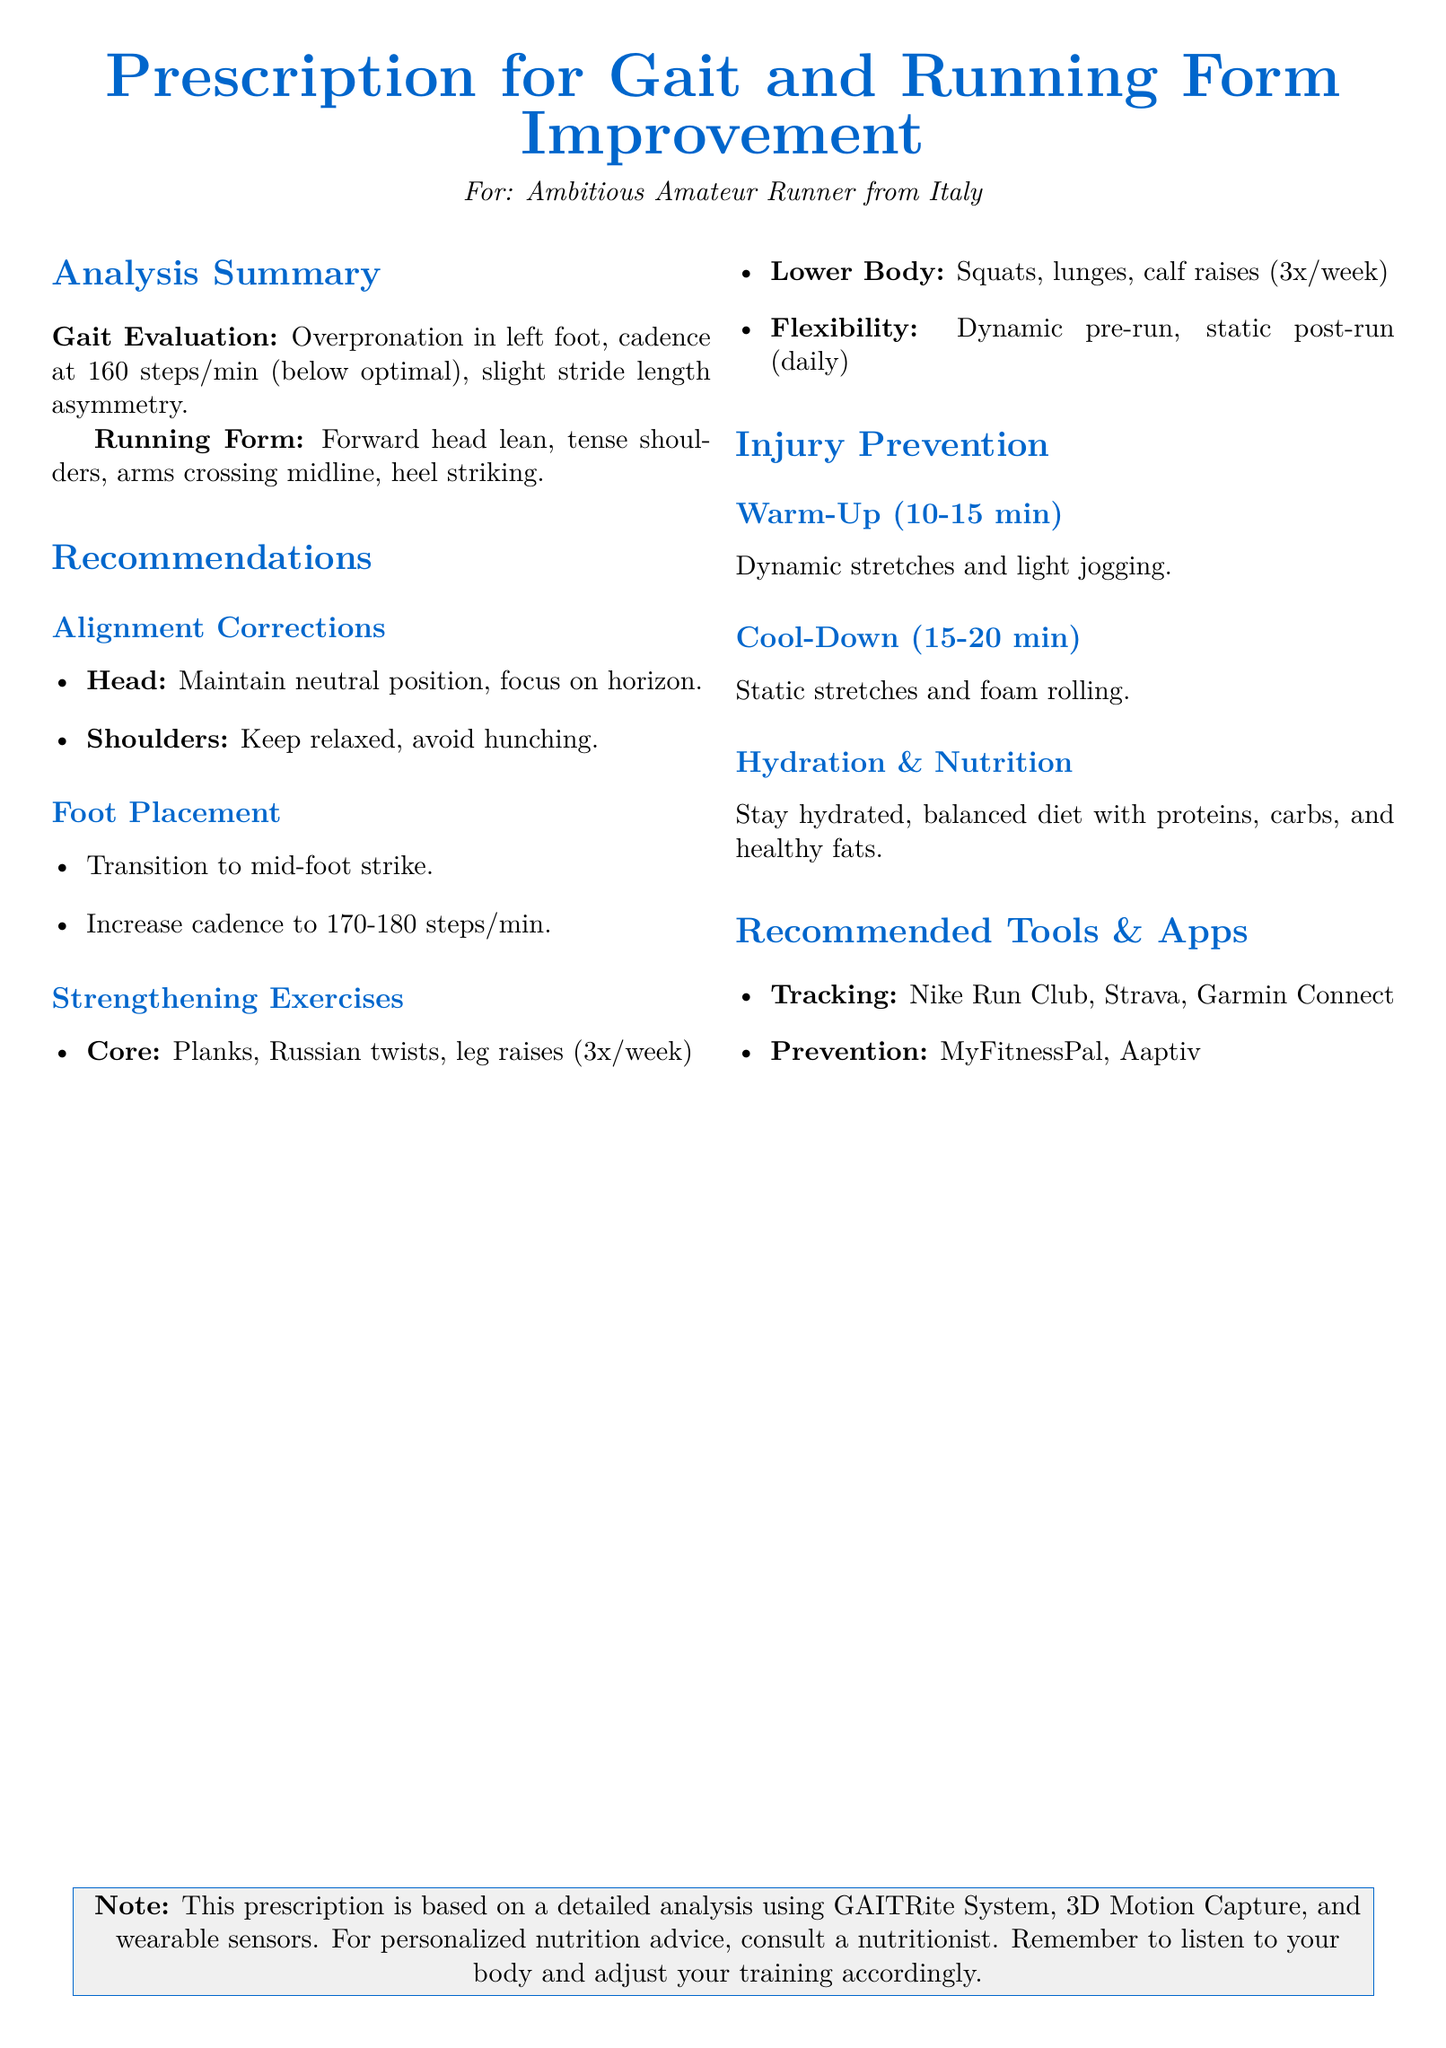What is the cadence of the runner? The cadence is noted in the analysis summary, specifically mentioned as 160 steps/min.
Answer: 160 steps/min What is indicated about the left foot? The document states that there is overpronation in the left foot according to the gait evaluation.
Answer: Overpronation What should the cadence be increased to? The recommendations suggest increasing the cadence to a specific range, which is 170-180 steps/min.
Answer: 170-180 steps/min What type of running strike is recommended? The document advises a transition to mid-foot strike as per the foot placement recommendations.
Answer: Mid-foot strike How often should core exercises be performed? The recommendations specify that core exercises should be done 3 times a week.
Answer: 3 times a week What is suggested for the warm-up? The warm-up recommendation includes dynamic stretches and light jogging for a set duration.
Answer: Dynamic stretches and light jogging What is the purpose of foam rolling in the cool-down? Foam rolling is included in the cool-down section to aid in recovery after running.
Answer: Recovery What type of diet is recommended? The document advises a balanced diet which should include a combination of macronutrients.
Answer: Balanced diet 